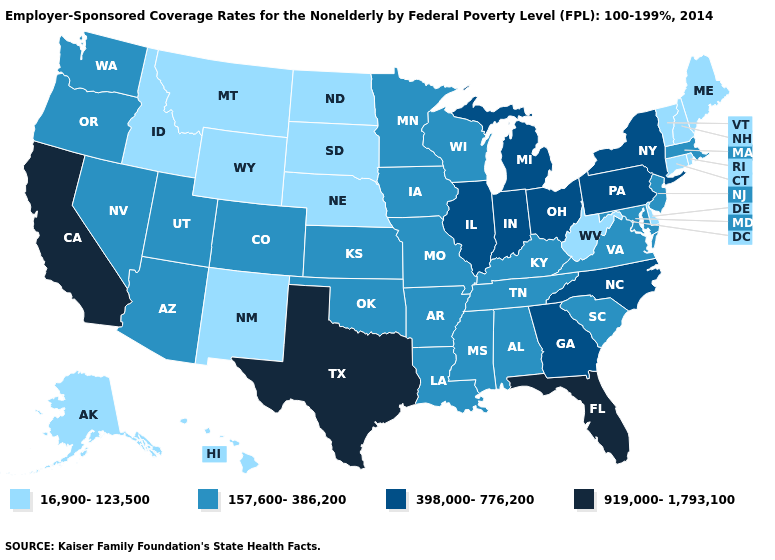Is the legend a continuous bar?
Answer briefly. No. Name the states that have a value in the range 919,000-1,793,100?
Keep it brief. California, Florida, Texas. Among the states that border Missouri , does Nebraska have the lowest value?
Keep it brief. Yes. What is the lowest value in the South?
Keep it brief. 16,900-123,500. Among the states that border South Dakota , which have the lowest value?
Keep it brief. Montana, Nebraska, North Dakota, Wyoming. What is the value of New York?
Write a very short answer. 398,000-776,200. Does the first symbol in the legend represent the smallest category?
Be succinct. Yes. Does Maine have the lowest value in the Northeast?
Be succinct. Yes. Among the states that border Michigan , which have the highest value?
Answer briefly. Indiana, Ohio. Does Illinois have the same value as New Jersey?
Write a very short answer. No. Among the states that border North Dakota , does Minnesota have the highest value?
Be succinct. Yes. What is the value of Texas?
Be succinct. 919,000-1,793,100. Name the states that have a value in the range 16,900-123,500?
Be succinct. Alaska, Connecticut, Delaware, Hawaii, Idaho, Maine, Montana, Nebraska, New Hampshire, New Mexico, North Dakota, Rhode Island, South Dakota, Vermont, West Virginia, Wyoming. Is the legend a continuous bar?
Quick response, please. No. 